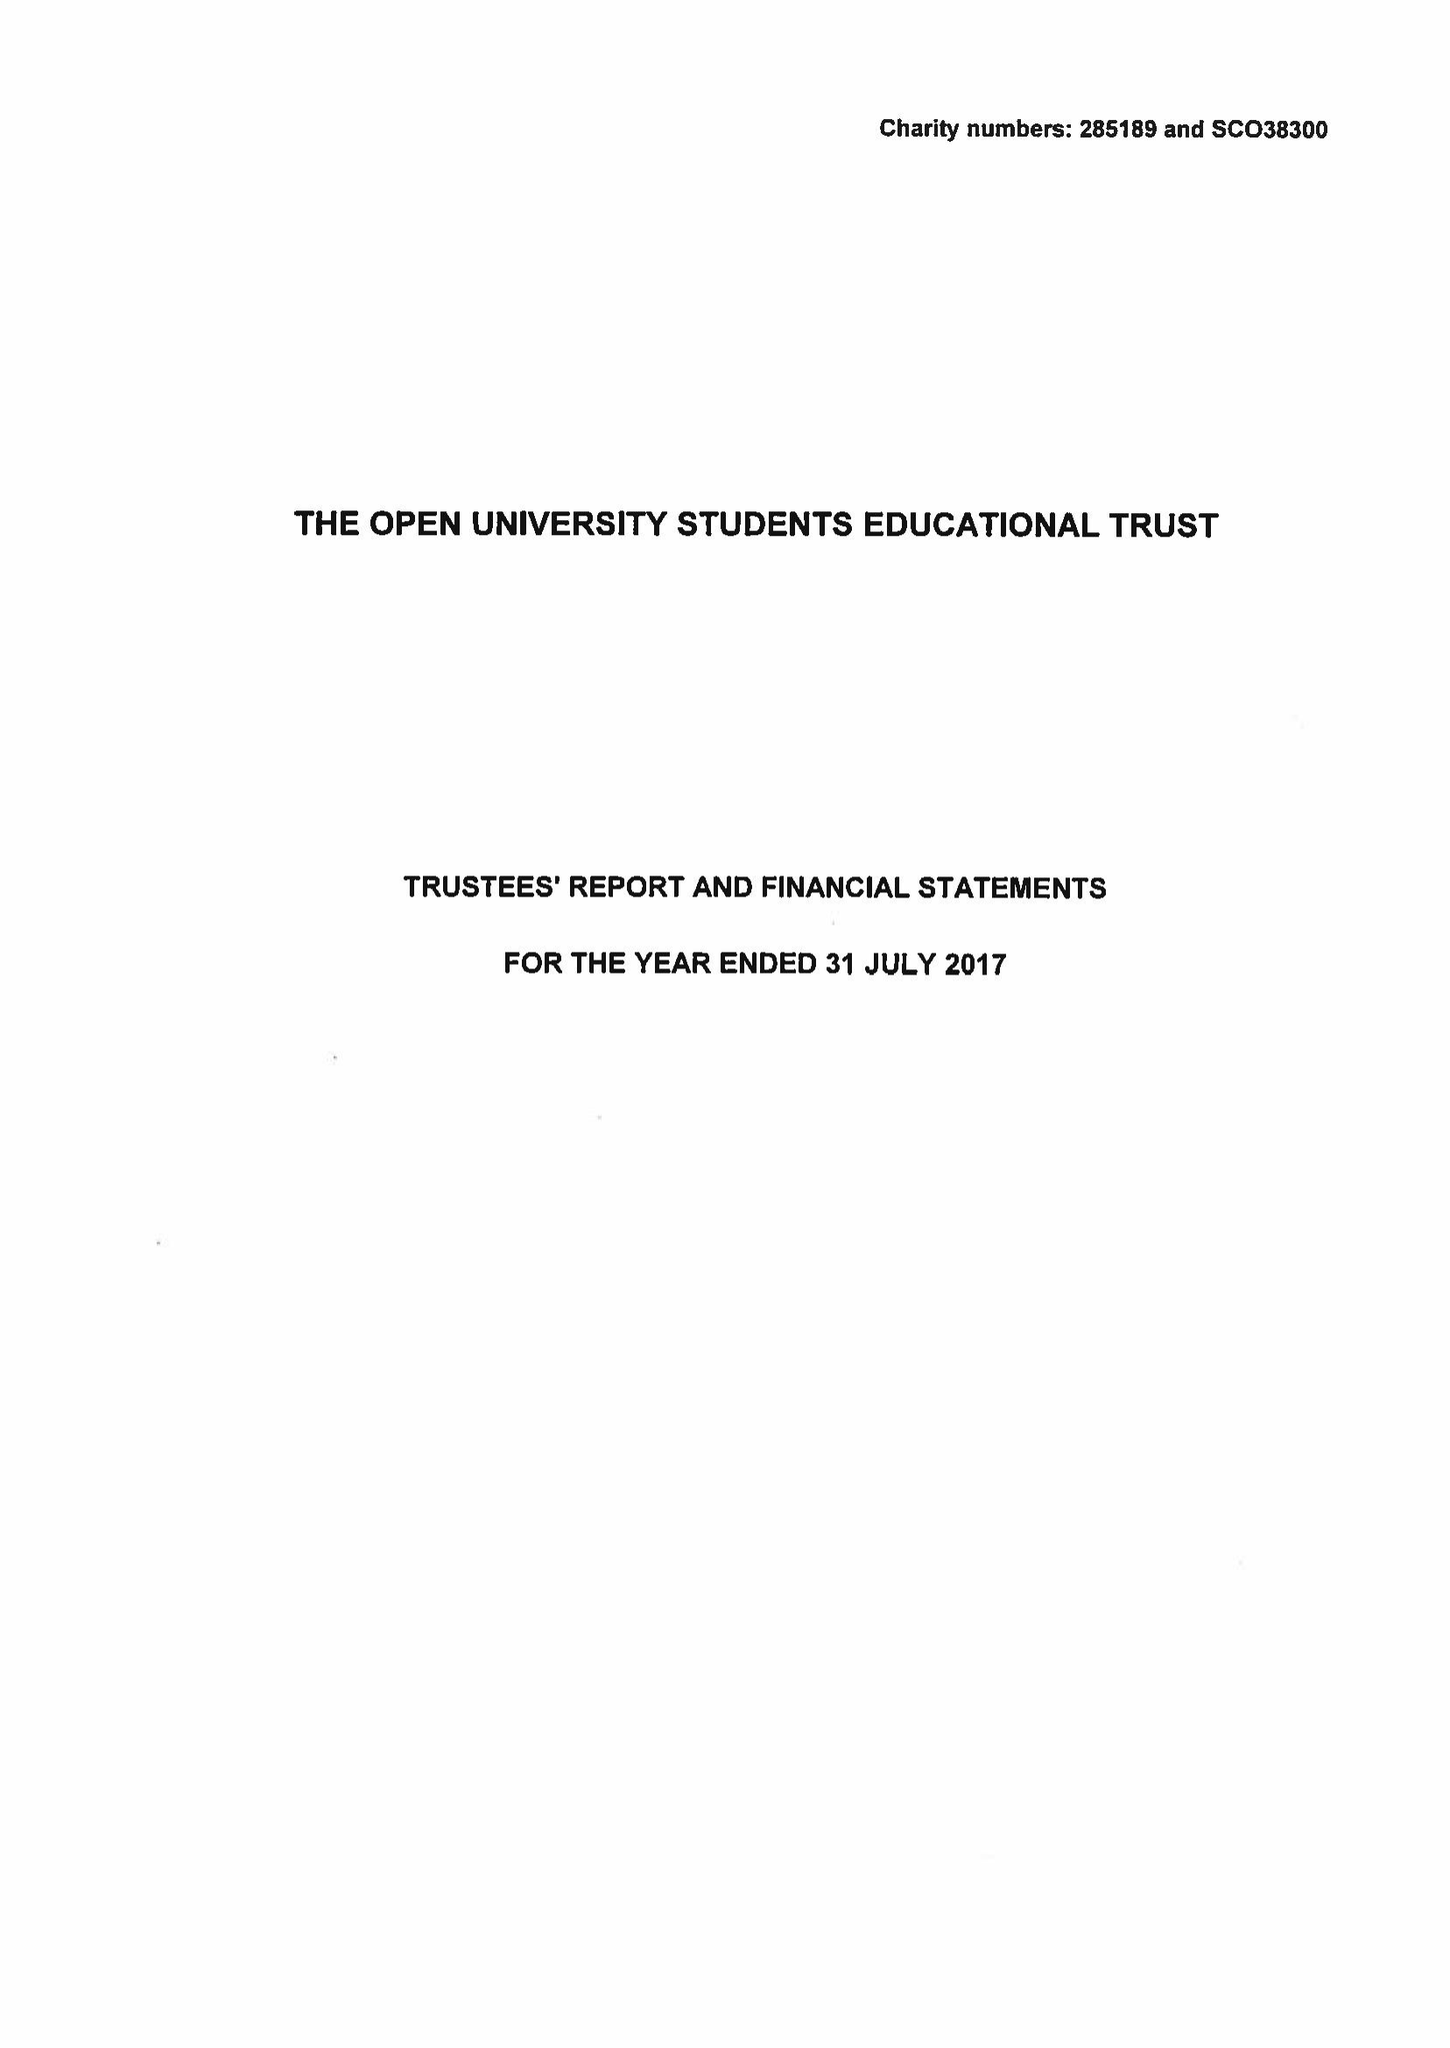What is the value for the address__street_line?
Answer the question using a single word or phrase. PO BOX 397 